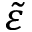Convert formula to latex. <formula><loc_0><loc_0><loc_500><loc_500>\tilde { \varepsilon }</formula> 